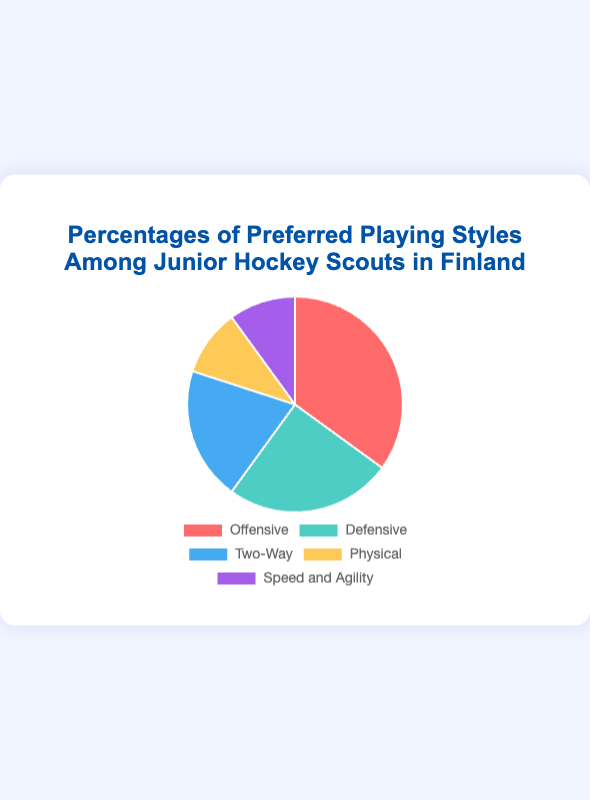What percentage of junior hockey scouts in Finland prefer the Two-Way playing style? The "Two-Way" playing style is labeled in the pie chart, and its corresponding percentage is shown as 20%.
Answer: 20% Which playing style is preferred by the smallest percentage of junior hockey scouts? By looking at the pie chart and comparing all the segments, it's clear that "Physical" and "Speed and Agility" both have the smallest percentage, each with 10%.
Answer: Physical and Speed and Agility What is the combined percentage of scouts who prefer Defensive and Physical playing styles? Add the percentages for "Defensive" (25%) and "Physical" (10%). 25% + 10% = 35%.
Answer: 35% How many playing styles have a percentage of preference that is less than 20%? Observing the pie chart, "Physical" and "Speed and Agility" each have 10%. Those are the two playing styles with percentages less than 20%.
Answer: 2 Which playing style has the highest preference among junior hockey scouts in Finland? The "Offensive" playing style segment is the largest in the pie chart and has the highest percentage of 35%.
Answer: Offensive What is the difference in preference between the Offensive and Two-Way playing styles? Subtract the percentage of "Two-Way" (20%) from the percentage of "Offensive" (35%). 35% - 20% = 15%.
Answer: 15% How does the preference for Speed and Agility compare with that for Defensive playing styles? "Speed and Agility" is preferred by 10% of scouts while "Defensive" is preferred by 25%. Therefore, "Defensive" is preferred more than "Speed and Agility".
Answer: Defensive is preferred more Which playing style uses the color red in the pie chart? The "Offensive" playing style segment is colored red in the pie chart.
Answer: Offensive 